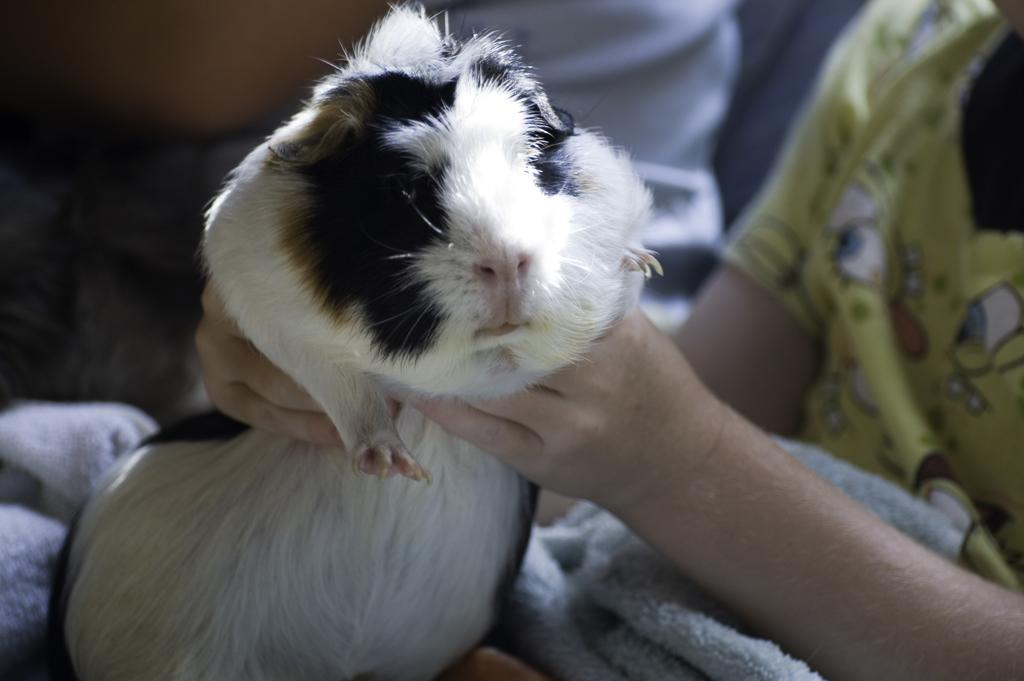What is the main subject of the image? There is a human in the image. What is the human doing in the image? The human is holding a hamster. Can you describe the hamster's appearance? The hamster is white, black, and brown in color. What else can be seen in the image? There is a cloth visible in the image. What type of vein is visible in the image? There is no vein visible in the image. What suggestion does the human make to the hamster in the image? The image does not depict any conversation or suggestion between the human and the hamster. 